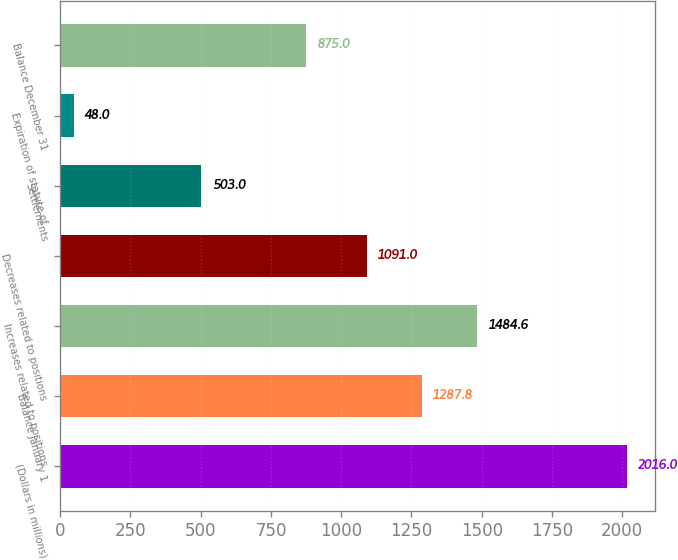<chart> <loc_0><loc_0><loc_500><loc_500><bar_chart><fcel>(Dollars in millions)<fcel>Balance January 1<fcel>Increases related to positions<fcel>Decreases related to positions<fcel>Settlements<fcel>Expiration of statute of<fcel>Balance December 31<nl><fcel>2016<fcel>1287.8<fcel>1484.6<fcel>1091<fcel>503<fcel>48<fcel>875<nl></chart> 